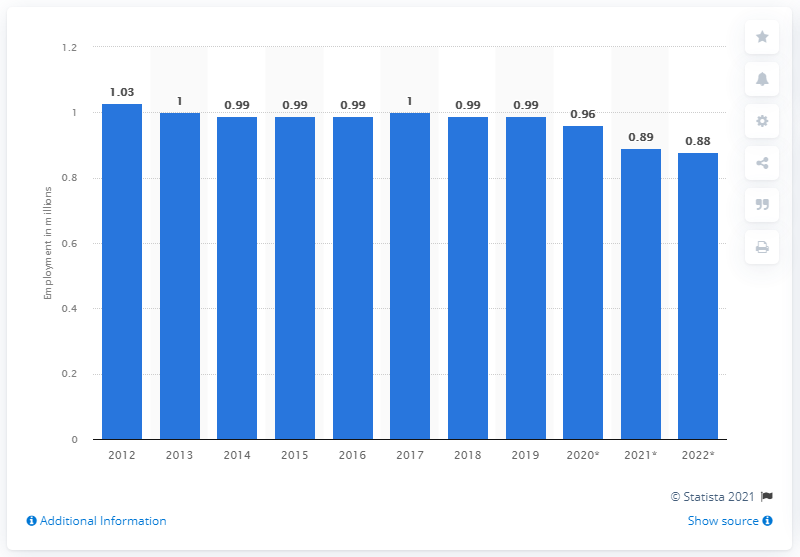Give some essential details in this illustration. In 2019, approximately 0.99% of the population of Puerto Rico was employed. 